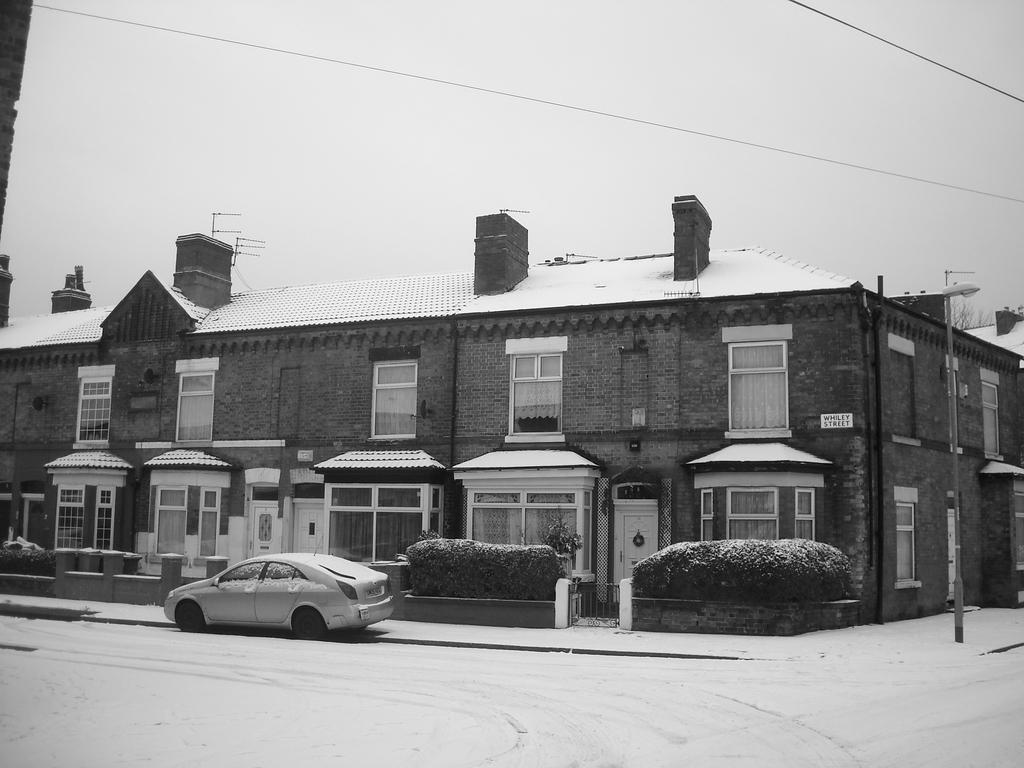What type of structure is visible in the image? There is a building in the image. What is located in front of the building? There are trees and plants in front of the building. Is there any transportation visible in the image? Yes, a vehicle is parked in front of the building. What can be seen in the background of the image? The sky is visible in the background of the image. How many cakes are being used as seeds in the image? There are no cakes or seeds present in the image. 